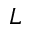Convert formula to latex. <formula><loc_0><loc_0><loc_500><loc_500>L</formula> 